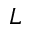Convert formula to latex. <formula><loc_0><loc_0><loc_500><loc_500>L</formula> 